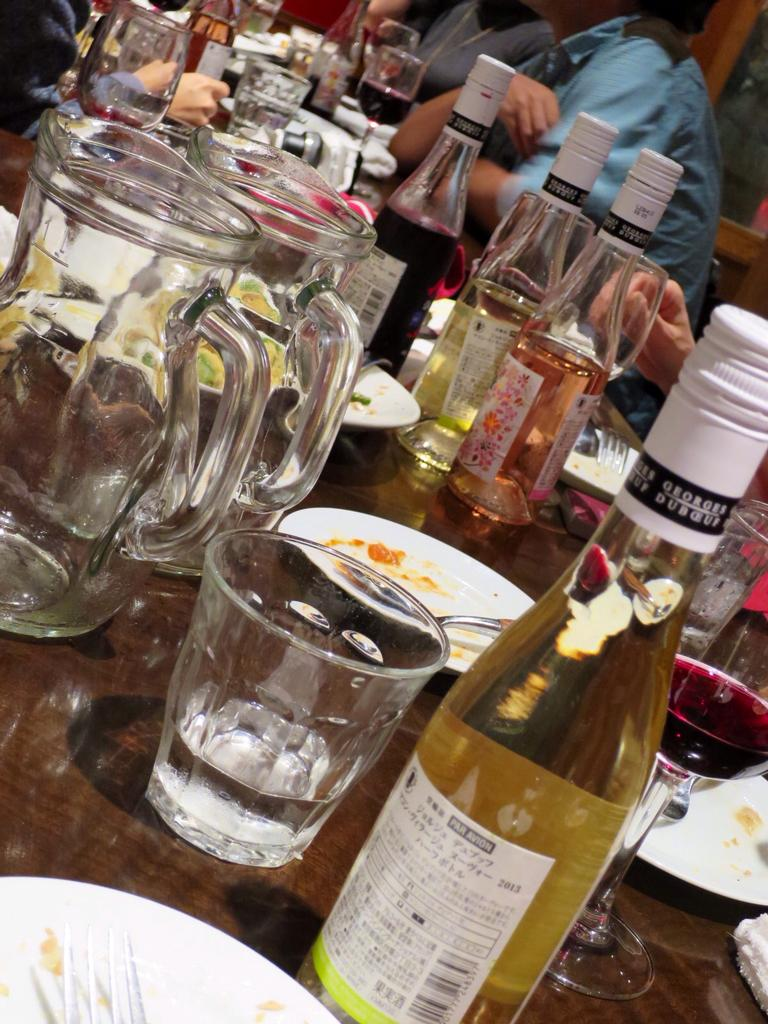What piece of furniture is present in the image? There is a table in the image. What items can be seen on the table? There are glasses, bottles, and plates on the table. Are there any people in the image? Yes, there are people sitting around the table. What type of nail is being hammered into the table in the image? There is no nail being hammered into the table in the image. Is there any sleet visible in the image? There is no mention of sleet in the provided facts, and it is not visible in the image. 